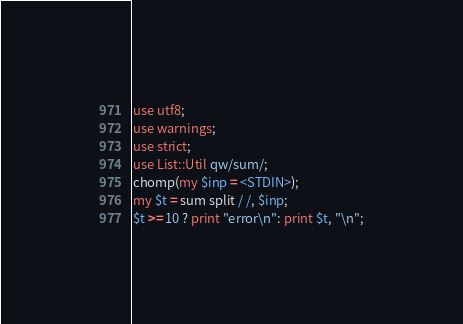Convert code to text. <code><loc_0><loc_0><loc_500><loc_500><_Perl_>use utf8;
use warnings;
use strict;
use List::Util qw/sum/;
chomp(my $inp = <STDIN>);
my $t = sum split / /, $inp;
$t >= 10 ? print "error\n": print $t, "\n";</code> 